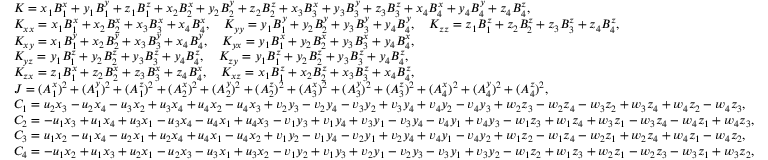Convert formula to latex. <formula><loc_0><loc_0><loc_500><loc_500>\begin{array} { r l } & { K = x _ { 1 } B _ { 1 } ^ { x } + y _ { 1 } B _ { 1 } ^ { y } + z _ { 1 } B _ { 1 } ^ { z } + x _ { 2 } B _ { 2 } ^ { x } + y _ { 2 } B _ { 2 } ^ { y } + z _ { 2 } B _ { 2 } ^ { z } + x _ { 3 } B _ { 3 } ^ { x } + y _ { 3 } B _ { 3 } ^ { y } + z _ { 3 } B _ { 3 } ^ { z } + x _ { 4 } B _ { 4 } ^ { x } + y _ { 4 } B _ { 4 } ^ { y } + z _ { 4 } B _ { 4 } ^ { z } , } \\ & { K _ { x x } = x _ { 1 } B _ { 1 } ^ { x } + x _ { 2 } B _ { 2 } ^ { x } + x _ { 3 } B _ { 3 } ^ { x } + x _ { 4 } B _ { 4 } ^ { x } , \quad K _ { y y } = y _ { 1 } B _ { 1 } ^ { y } + y _ { 2 } B _ { 2 } ^ { y } + y _ { 3 } B _ { 3 } ^ { y } + y _ { 4 } B _ { 4 } ^ { y } , \quad K _ { z z } = z _ { 1 } B _ { 1 } ^ { z } + z _ { 2 } B _ { 2 } ^ { z } + z _ { 3 } B _ { 3 } ^ { z } + z _ { 4 } B _ { 4 } ^ { z } , } \\ & { K _ { x y } = x _ { 1 } B _ { 1 } ^ { y } + x _ { 2 } B _ { 2 } ^ { y } + x _ { 3 } B _ { 3 } ^ { y } + x _ { 4 } B _ { 4 } ^ { y } , \quad K _ { y x } = y _ { 1 } B _ { 1 } ^ { x } + y _ { 2 } B _ { 2 } ^ { x } + y _ { 3 } B _ { 3 } ^ { x } + y _ { 4 } B _ { 4 } ^ { x } , } \\ & { K _ { y z } = y _ { 1 } B _ { 1 } ^ { z } + y _ { 2 } B _ { 2 } ^ { z } + y _ { 3 } B _ { 3 } ^ { z } + y _ { 4 } B _ { 4 } ^ { z } , \quad K _ { z y } = y _ { 1 } B _ { 1 } ^ { z } + y _ { 2 } B _ { 2 } ^ { z } + y _ { 3 } B _ { 3 } ^ { z } + y _ { 4 } B _ { 4 } ^ { z } , } \\ & { K _ { z x } = z _ { 1 } B _ { 1 } ^ { x } + z _ { 2 } B _ { 2 } ^ { x } + z _ { 3 } B _ { 3 } ^ { x } + z _ { 4 } B _ { 4 } ^ { x } , \quad K _ { x z } = x _ { 1 } B _ { 1 } ^ { z } + x _ { 2 } B _ { 2 } ^ { z } + x _ { 3 } B _ { 3 } ^ { z } + x _ { 4 } B _ { 4 } ^ { z } , } \\ & { J = ( A _ { 1 } ^ { x } ) ^ { 2 } + ( A _ { 1 } ^ { y } ) ^ { 2 } + ( A _ { 1 } ^ { z } ) ^ { 2 } + ( A _ { 2 } ^ { x } ) ^ { 2 } + ( A _ { 2 } ^ { y } ) ^ { 2 } + ( A _ { 2 } ^ { z } ) ^ { 2 } + ( A _ { 3 } ^ { x } ) ^ { 2 } + ( A _ { 3 } ^ { y } ) ^ { 2 } + ( A _ { 3 } ^ { z } ) ^ { 2 } + ( A _ { 4 } ^ { x } ) ^ { 2 } + ( A _ { 4 } ^ { y } ) ^ { 2 } + ( A _ { 4 } ^ { z } ) ^ { 2 } , } \\ & { C _ { 1 } = u _ { 2 } x _ { 3 } - u _ { 2 } x _ { 4 } - u _ { 3 } x _ { 2 } + u _ { 3 } x _ { 4 } + u _ { 4 } x _ { 2 } - u _ { 4 } x _ { 3 } + v _ { 2 } y _ { 3 } - v _ { 2 } y _ { 4 } - v _ { 3 } y _ { 2 } + v _ { 3 } y _ { 4 } + v _ { 4 } y _ { 2 } - v _ { 4 } y _ { 3 } + w _ { 2 } z _ { 3 } - w _ { 2 } z _ { 4 } - w _ { 3 } z _ { 2 } + w _ { 3 } z _ { 4 } + w _ { 4 } z _ { 2 } - w _ { 4 } z _ { 3 } , } \\ & { C _ { 2 } = - u _ { 1 } x _ { 3 } + u _ { 1 } x _ { 4 } + u _ { 3 } x _ { 1 } - u _ { 3 } x _ { 4 } - u _ { 4 } x _ { 1 } + u _ { 4 } x _ { 3 } - v _ { 1 } y _ { 3 } + v _ { 1 } y _ { 4 } + v _ { 3 } y _ { 1 } - v _ { 3 } y _ { 4 } - v _ { 4 } y _ { 1 } + v _ { 4 } y _ { 3 } - w _ { 1 } z _ { 3 } + w _ { 1 } z _ { 4 } + w _ { 3 } z _ { 1 } - w _ { 3 } z _ { 4 } - w _ { 4 } z _ { 1 } + w _ { 4 } z _ { 3 } , } \\ & { C _ { 3 } = u _ { 1 } x _ { 2 } - u _ { 1 } x _ { 4 } - u _ { 2 } x _ { 1 } + u _ { 2 } x _ { 4 } + u _ { 4 } x _ { 1 } - u _ { 4 } x _ { 2 } + v _ { 1 } y _ { 2 } - v _ { 1 } y _ { 4 } - v _ { 2 } y _ { 1 } + v _ { 2 } y _ { 4 } + v _ { 4 } y _ { 1 } - v _ { 4 } y _ { 2 } + w _ { 1 } z _ { 2 } - w _ { 1 } z _ { 4 } - w _ { 2 } z _ { 1 } + w _ { 2 } z _ { 4 } + w _ { 4 } z _ { 1 } - w _ { 4 } z _ { 2 } , } \\ & { C _ { 4 } = - u _ { 1 } x _ { 2 } + u _ { 1 } x _ { 3 } + u _ { 2 } x _ { 1 } - u _ { 2 } x _ { 3 } - u _ { 3 } x _ { 1 } + u _ { 3 } x _ { 2 } - v _ { 1 } y _ { 2 } + v _ { 1 } y _ { 3 } + v _ { 2 } y _ { 1 } - v _ { 2 } y _ { 3 } - v _ { 3 } y _ { 1 } + v _ { 3 } y _ { 2 } - w _ { 1 } z _ { 2 } + w _ { 1 } z _ { 3 } + w _ { 2 } z _ { 1 } - w _ { 2 } z _ { 3 } - w _ { 3 } z _ { 1 } + w _ { 3 } z _ { 2 } , } \end{array}</formula> 